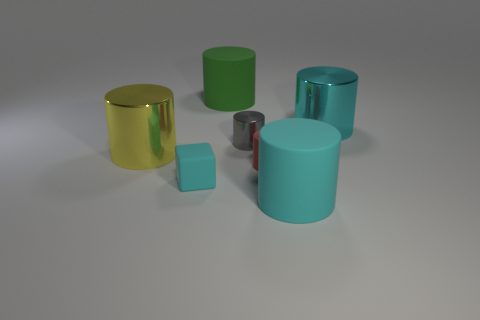There is a large cyan thing to the right of the large thing that is in front of the large yellow cylinder; what is its shape?
Your answer should be compact. Cylinder. There is a gray object that is the same shape as the big cyan shiny thing; what is it made of?
Your response must be concise. Metal. The other metal thing that is the same size as the yellow metallic object is what color?
Make the answer very short. Cyan. Are there an equal number of large objects that are on the right side of the tiny red matte thing and big rubber objects?
Your answer should be compact. Yes. The big metallic object to the left of the big cylinder that is in front of the tiny red rubber object is what color?
Give a very brief answer. Yellow. There is a gray shiny thing on the left side of the cyan shiny cylinder that is on the right side of the tiny gray object; how big is it?
Make the answer very short. Small. How many other things are the same size as the gray shiny cylinder?
Provide a short and direct response. 2. The large rubber cylinder that is behind the large cyan cylinder in front of the big metallic cylinder behind the small gray thing is what color?
Your response must be concise. Green. How many other things are the same shape as the cyan metallic object?
Make the answer very short. 5. There is a large shiny object on the left side of the tiny red matte cylinder; what shape is it?
Your answer should be very brief. Cylinder. 